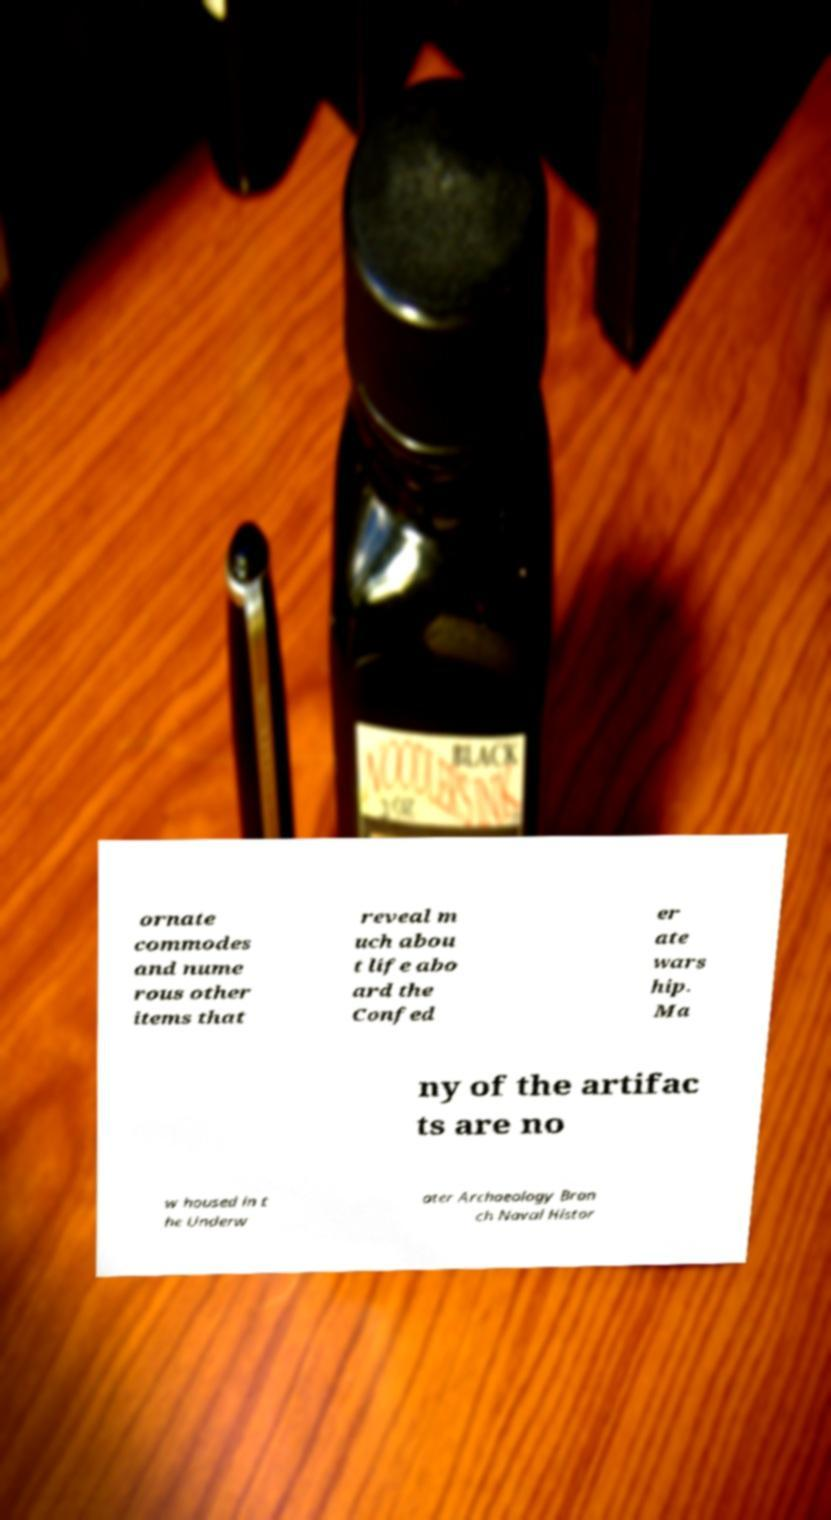Please read and relay the text visible in this image. What does it say? ornate commodes and nume rous other items that reveal m uch abou t life abo ard the Confed er ate wars hip. Ma ny of the artifac ts are no w housed in t he Underw ater Archaeology Bran ch Naval Histor 